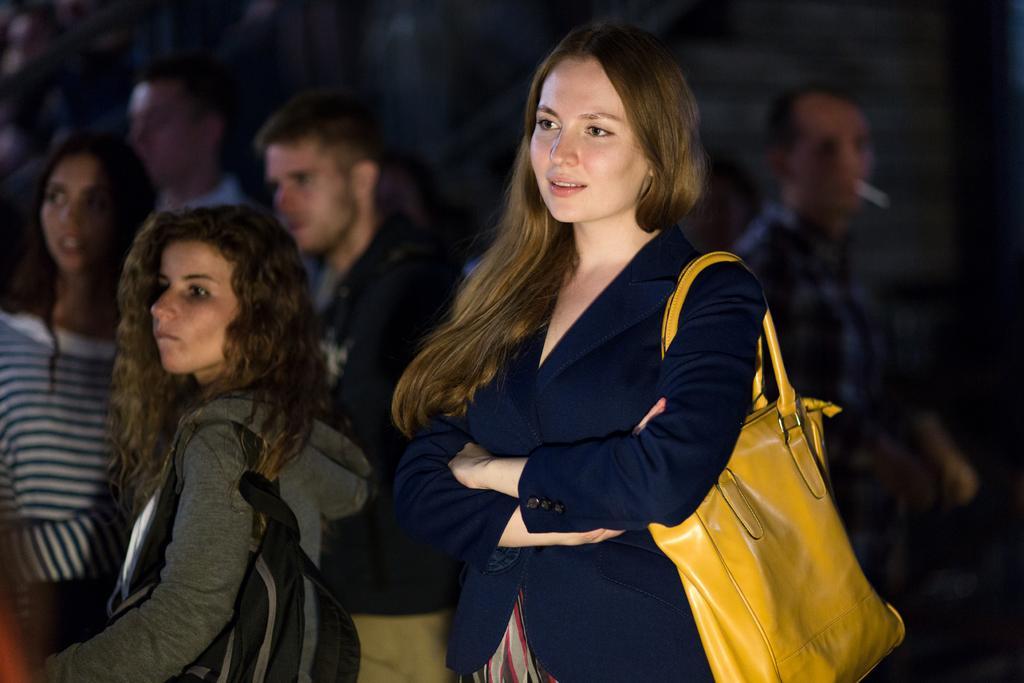How would you summarize this image in a sentence or two? A picture with group of people where a lady is highlighted who is wearing a blue color jacket and a yellow hand bag. 